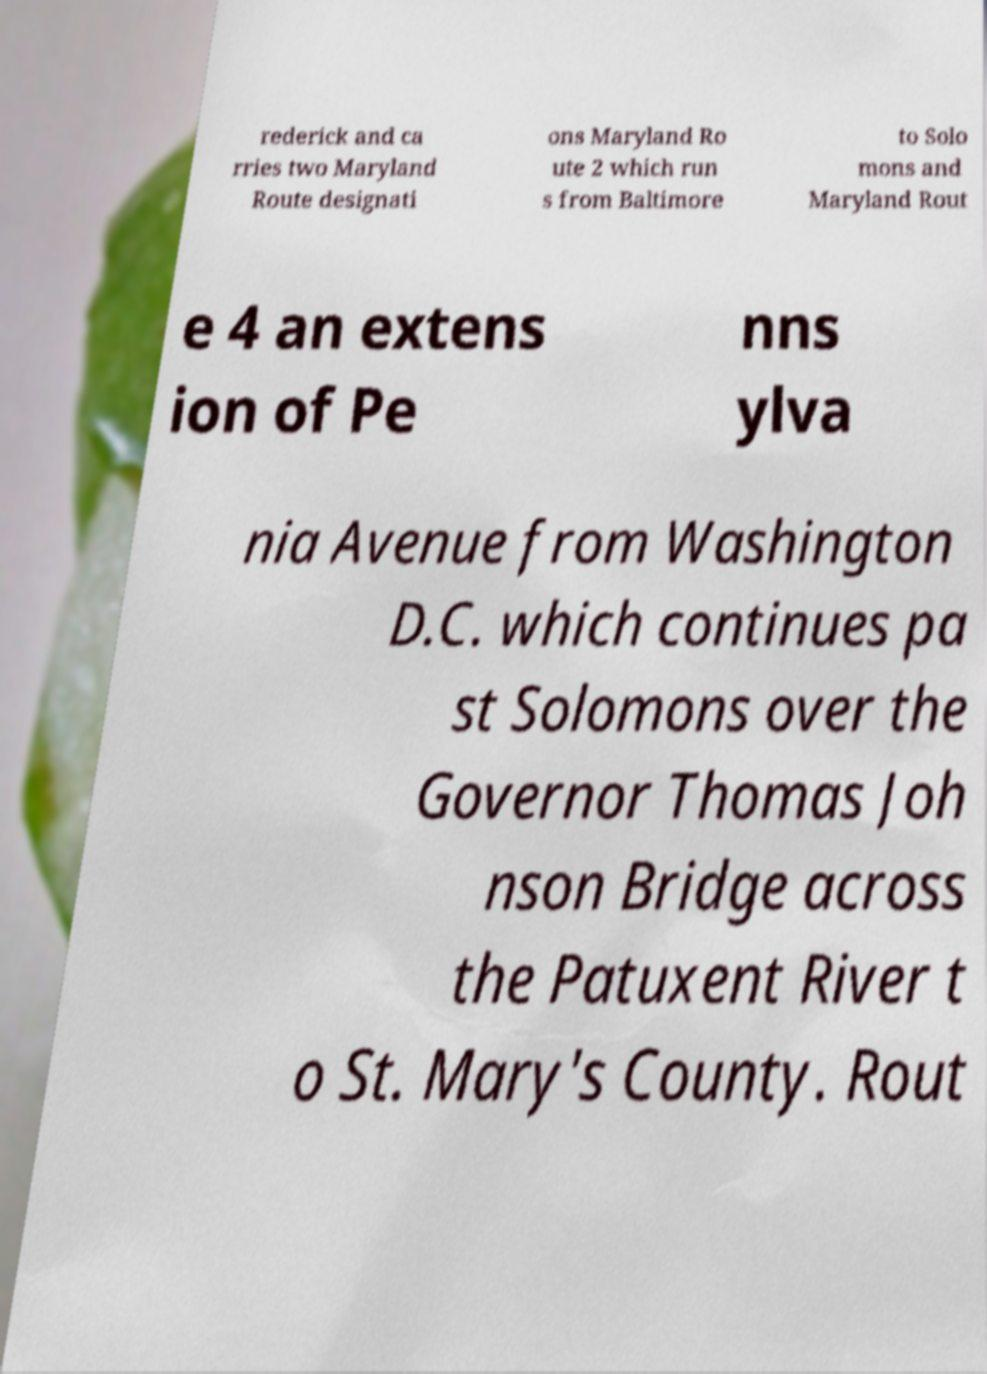Please identify and transcribe the text found in this image. rederick and ca rries two Maryland Route designati ons Maryland Ro ute 2 which run s from Baltimore to Solo mons and Maryland Rout e 4 an extens ion of Pe nns ylva nia Avenue from Washington D.C. which continues pa st Solomons over the Governor Thomas Joh nson Bridge across the Patuxent River t o St. Mary's County. Rout 